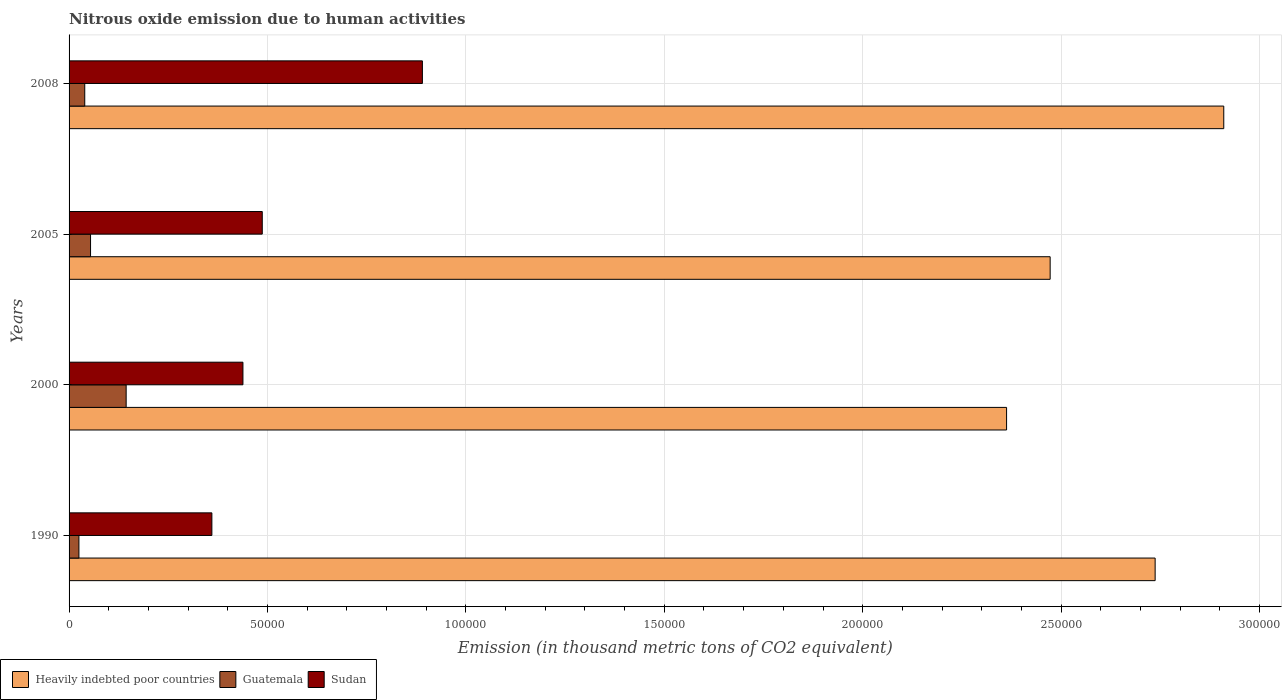How many groups of bars are there?
Keep it short and to the point. 4. How many bars are there on the 2nd tick from the bottom?
Provide a succinct answer. 3. What is the label of the 3rd group of bars from the top?
Your answer should be compact. 2000. In how many cases, is the number of bars for a given year not equal to the number of legend labels?
Your response must be concise. 0. What is the amount of nitrous oxide emitted in Sudan in 2005?
Your response must be concise. 4.87e+04. Across all years, what is the maximum amount of nitrous oxide emitted in Guatemala?
Ensure brevity in your answer.  1.44e+04. Across all years, what is the minimum amount of nitrous oxide emitted in Sudan?
Offer a very short reply. 3.60e+04. What is the total amount of nitrous oxide emitted in Guatemala in the graph?
Offer a very short reply. 2.62e+04. What is the difference between the amount of nitrous oxide emitted in Sudan in 2000 and that in 2005?
Offer a terse response. -4871.9. What is the difference between the amount of nitrous oxide emitted in Heavily indebted poor countries in 1990 and the amount of nitrous oxide emitted in Sudan in 2000?
Keep it short and to the point. 2.30e+05. What is the average amount of nitrous oxide emitted in Guatemala per year?
Keep it short and to the point. 6558.1. In the year 1990, what is the difference between the amount of nitrous oxide emitted in Guatemala and amount of nitrous oxide emitted in Heavily indebted poor countries?
Ensure brevity in your answer.  -2.71e+05. What is the ratio of the amount of nitrous oxide emitted in Guatemala in 2005 to that in 2008?
Your answer should be very brief. 1.37. Is the difference between the amount of nitrous oxide emitted in Guatemala in 2000 and 2008 greater than the difference between the amount of nitrous oxide emitted in Heavily indebted poor countries in 2000 and 2008?
Make the answer very short. Yes. What is the difference between the highest and the second highest amount of nitrous oxide emitted in Guatemala?
Give a very brief answer. 8972.6. What is the difference between the highest and the lowest amount of nitrous oxide emitted in Guatemala?
Your response must be concise. 1.19e+04. In how many years, is the amount of nitrous oxide emitted in Guatemala greater than the average amount of nitrous oxide emitted in Guatemala taken over all years?
Offer a very short reply. 1. What does the 2nd bar from the top in 2005 represents?
Offer a terse response. Guatemala. What does the 2nd bar from the bottom in 1990 represents?
Make the answer very short. Guatemala. Is it the case that in every year, the sum of the amount of nitrous oxide emitted in Guatemala and amount of nitrous oxide emitted in Sudan is greater than the amount of nitrous oxide emitted in Heavily indebted poor countries?
Provide a short and direct response. No. How many bars are there?
Your response must be concise. 12. Are all the bars in the graph horizontal?
Your answer should be compact. Yes. How many years are there in the graph?
Provide a succinct answer. 4. What is the difference between two consecutive major ticks on the X-axis?
Your answer should be very brief. 5.00e+04. Are the values on the major ticks of X-axis written in scientific E-notation?
Provide a succinct answer. No. Does the graph contain any zero values?
Provide a short and direct response. No. How many legend labels are there?
Your answer should be compact. 3. How are the legend labels stacked?
Ensure brevity in your answer.  Horizontal. What is the title of the graph?
Your answer should be very brief. Nitrous oxide emission due to human activities. Does "Belarus" appear as one of the legend labels in the graph?
Provide a succinct answer. No. What is the label or title of the X-axis?
Make the answer very short. Emission (in thousand metric tons of CO2 equivalent). What is the Emission (in thousand metric tons of CO2 equivalent) of Heavily indebted poor countries in 1990?
Your answer should be compact. 2.74e+05. What is the Emission (in thousand metric tons of CO2 equivalent) of Guatemala in 1990?
Make the answer very short. 2483.4. What is the Emission (in thousand metric tons of CO2 equivalent) in Sudan in 1990?
Offer a terse response. 3.60e+04. What is the Emission (in thousand metric tons of CO2 equivalent) of Heavily indebted poor countries in 2000?
Give a very brief answer. 2.36e+05. What is the Emission (in thousand metric tons of CO2 equivalent) in Guatemala in 2000?
Make the answer very short. 1.44e+04. What is the Emission (in thousand metric tons of CO2 equivalent) of Sudan in 2000?
Your response must be concise. 4.38e+04. What is the Emission (in thousand metric tons of CO2 equivalent) of Heavily indebted poor countries in 2005?
Your answer should be very brief. 2.47e+05. What is the Emission (in thousand metric tons of CO2 equivalent) of Guatemala in 2005?
Ensure brevity in your answer.  5413.1. What is the Emission (in thousand metric tons of CO2 equivalent) of Sudan in 2005?
Your answer should be very brief. 4.87e+04. What is the Emission (in thousand metric tons of CO2 equivalent) of Heavily indebted poor countries in 2008?
Your answer should be compact. 2.91e+05. What is the Emission (in thousand metric tons of CO2 equivalent) of Guatemala in 2008?
Give a very brief answer. 3950.2. What is the Emission (in thousand metric tons of CO2 equivalent) of Sudan in 2008?
Offer a terse response. 8.90e+04. Across all years, what is the maximum Emission (in thousand metric tons of CO2 equivalent) of Heavily indebted poor countries?
Give a very brief answer. 2.91e+05. Across all years, what is the maximum Emission (in thousand metric tons of CO2 equivalent) of Guatemala?
Your answer should be very brief. 1.44e+04. Across all years, what is the maximum Emission (in thousand metric tons of CO2 equivalent) of Sudan?
Your response must be concise. 8.90e+04. Across all years, what is the minimum Emission (in thousand metric tons of CO2 equivalent) in Heavily indebted poor countries?
Ensure brevity in your answer.  2.36e+05. Across all years, what is the minimum Emission (in thousand metric tons of CO2 equivalent) in Guatemala?
Give a very brief answer. 2483.4. Across all years, what is the minimum Emission (in thousand metric tons of CO2 equivalent) of Sudan?
Your response must be concise. 3.60e+04. What is the total Emission (in thousand metric tons of CO2 equivalent) in Heavily indebted poor countries in the graph?
Offer a terse response. 1.05e+06. What is the total Emission (in thousand metric tons of CO2 equivalent) of Guatemala in the graph?
Ensure brevity in your answer.  2.62e+04. What is the total Emission (in thousand metric tons of CO2 equivalent) of Sudan in the graph?
Provide a succinct answer. 2.18e+05. What is the difference between the Emission (in thousand metric tons of CO2 equivalent) in Heavily indebted poor countries in 1990 and that in 2000?
Ensure brevity in your answer.  3.74e+04. What is the difference between the Emission (in thousand metric tons of CO2 equivalent) of Guatemala in 1990 and that in 2000?
Give a very brief answer. -1.19e+04. What is the difference between the Emission (in thousand metric tons of CO2 equivalent) of Sudan in 1990 and that in 2000?
Offer a very short reply. -7827.3. What is the difference between the Emission (in thousand metric tons of CO2 equivalent) in Heavily indebted poor countries in 1990 and that in 2005?
Your answer should be compact. 2.65e+04. What is the difference between the Emission (in thousand metric tons of CO2 equivalent) of Guatemala in 1990 and that in 2005?
Give a very brief answer. -2929.7. What is the difference between the Emission (in thousand metric tons of CO2 equivalent) in Sudan in 1990 and that in 2005?
Your answer should be compact. -1.27e+04. What is the difference between the Emission (in thousand metric tons of CO2 equivalent) in Heavily indebted poor countries in 1990 and that in 2008?
Offer a terse response. -1.73e+04. What is the difference between the Emission (in thousand metric tons of CO2 equivalent) of Guatemala in 1990 and that in 2008?
Offer a terse response. -1466.8. What is the difference between the Emission (in thousand metric tons of CO2 equivalent) in Sudan in 1990 and that in 2008?
Offer a very short reply. -5.31e+04. What is the difference between the Emission (in thousand metric tons of CO2 equivalent) of Heavily indebted poor countries in 2000 and that in 2005?
Your answer should be very brief. -1.10e+04. What is the difference between the Emission (in thousand metric tons of CO2 equivalent) in Guatemala in 2000 and that in 2005?
Make the answer very short. 8972.6. What is the difference between the Emission (in thousand metric tons of CO2 equivalent) in Sudan in 2000 and that in 2005?
Provide a short and direct response. -4871.9. What is the difference between the Emission (in thousand metric tons of CO2 equivalent) in Heavily indebted poor countries in 2000 and that in 2008?
Your response must be concise. -5.47e+04. What is the difference between the Emission (in thousand metric tons of CO2 equivalent) of Guatemala in 2000 and that in 2008?
Ensure brevity in your answer.  1.04e+04. What is the difference between the Emission (in thousand metric tons of CO2 equivalent) of Sudan in 2000 and that in 2008?
Keep it short and to the point. -4.52e+04. What is the difference between the Emission (in thousand metric tons of CO2 equivalent) in Heavily indebted poor countries in 2005 and that in 2008?
Your answer should be compact. -4.38e+04. What is the difference between the Emission (in thousand metric tons of CO2 equivalent) of Guatemala in 2005 and that in 2008?
Your answer should be very brief. 1462.9. What is the difference between the Emission (in thousand metric tons of CO2 equivalent) in Sudan in 2005 and that in 2008?
Ensure brevity in your answer.  -4.04e+04. What is the difference between the Emission (in thousand metric tons of CO2 equivalent) of Heavily indebted poor countries in 1990 and the Emission (in thousand metric tons of CO2 equivalent) of Guatemala in 2000?
Make the answer very short. 2.59e+05. What is the difference between the Emission (in thousand metric tons of CO2 equivalent) in Heavily indebted poor countries in 1990 and the Emission (in thousand metric tons of CO2 equivalent) in Sudan in 2000?
Your answer should be compact. 2.30e+05. What is the difference between the Emission (in thousand metric tons of CO2 equivalent) in Guatemala in 1990 and the Emission (in thousand metric tons of CO2 equivalent) in Sudan in 2000?
Your answer should be compact. -4.13e+04. What is the difference between the Emission (in thousand metric tons of CO2 equivalent) in Heavily indebted poor countries in 1990 and the Emission (in thousand metric tons of CO2 equivalent) in Guatemala in 2005?
Offer a terse response. 2.68e+05. What is the difference between the Emission (in thousand metric tons of CO2 equivalent) in Heavily indebted poor countries in 1990 and the Emission (in thousand metric tons of CO2 equivalent) in Sudan in 2005?
Ensure brevity in your answer.  2.25e+05. What is the difference between the Emission (in thousand metric tons of CO2 equivalent) in Guatemala in 1990 and the Emission (in thousand metric tons of CO2 equivalent) in Sudan in 2005?
Provide a short and direct response. -4.62e+04. What is the difference between the Emission (in thousand metric tons of CO2 equivalent) in Heavily indebted poor countries in 1990 and the Emission (in thousand metric tons of CO2 equivalent) in Guatemala in 2008?
Make the answer very short. 2.70e+05. What is the difference between the Emission (in thousand metric tons of CO2 equivalent) of Heavily indebted poor countries in 1990 and the Emission (in thousand metric tons of CO2 equivalent) of Sudan in 2008?
Ensure brevity in your answer.  1.85e+05. What is the difference between the Emission (in thousand metric tons of CO2 equivalent) of Guatemala in 1990 and the Emission (in thousand metric tons of CO2 equivalent) of Sudan in 2008?
Offer a terse response. -8.66e+04. What is the difference between the Emission (in thousand metric tons of CO2 equivalent) in Heavily indebted poor countries in 2000 and the Emission (in thousand metric tons of CO2 equivalent) in Guatemala in 2005?
Provide a short and direct response. 2.31e+05. What is the difference between the Emission (in thousand metric tons of CO2 equivalent) in Heavily indebted poor countries in 2000 and the Emission (in thousand metric tons of CO2 equivalent) in Sudan in 2005?
Give a very brief answer. 1.88e+05. What is the difference between the Emission (in thousand metric tons of CO2 equivalent) in Guatemala in 2000 and the Emission (in thousand metric tons of CO2 equivalent) in Sudan in 2005?
Your answer should be very brief. -3.43e+04. What is the difference between the Emission (in thousand metric tons of CO2 equivalent) of Heavily indebted poor countries in 2000 and the Emission (in thousand metric tons of CO2 equivalent) of Guatemala in 2008?
Your response must be concise. 2.32e+05. What is the difference between the Emission (in thousand metric tons of CO2 equivalent) of Heavily indebted poor countries in 2000 and the Emission (in thousand metric tons of CO2 equivalent) of Sudan in 2008?
Keep it short and to the point. 1.47e+05. What is the difference between the Emission (in thousand metric tons of CO2 equivalent) in Guatemala in 2000 and the Emission (in thousand metric tons of CO2 equivalent) in Sudan in 2008?
Your answer should be very brief. -7.47e+04. What is the difference between the Emission (in thousand metric tons of CO2 equivalent) of Heavily indebted poor countries in 2005 and the Emission (in thousand metric tons of CO2 equivalent) of Guatemala in 2008?
Give a very brief answer. 2.43e+05. What is the difference between the Emission (in thousand metric tons of CO2 equivalent) of Heavily indebted poor countries in 2005 and the Emission (in thousand metric tons of CO2 equivalent) of Sudan in 2008?
Your response must be concise. 1.58e+05. What is the difference between the Emission (in thousand metric tons of CO2 equivalent) of Guatemala in 2005 and the Emission (in thousand metric tons of CO2 equivalent) of Sudan in 2008?
Provide a succinct answer. -8.36e+04. What is the average Emission (in thousand metric tons of CO2 equivalent) of Heavily indebted poor countries per year?
Provide a short and direct response. 2.62e+05. What is the average Emission (in thousand metric tons of CO2 equivalent) in Guatemala per year?
Ensure brevity in your answer.  6558.1. What is the average Emission (in thousand metric tons of CO2 equivalent) in Sudan per year?
Your answer should be compact. 5.44e+04. In the year 1990, what is the difference between the Emission (in thousand metric tons of CO2 equivalent) in Heavily indebted poor countries and Emission (in thousand metric tons of CO2 equivalent) in Guatemala?
Provide a short and direct response. 2.71e+05. In the year 1990, what is the difference between the Emission (in thousand metric tons of CO2 equivalent) of Heavily indebted poor countries and Emission (in thousand metric tons of CO2 equivalent) of Sudan?
Keep it short and to the point. 2.38e+05. In the year 1990, what is the difference between the Emission (in thousand metric tons of CO2 equivalent) of Guatemala and Emission (in thousand metric tons of CO2 equivalent) of Sudan?
Your response must be concise. -3.35e+04. In the year 2000, what is the difference between the Emission (in thousand metric tons of CO2 equivalent) of Heavily indebted poor countries and Emission (in thousand metric tons of CO2 equivalent) of Guatemala?
Offer a terse response. 2.22e+05. In the year 2000, what is the difference between the Emission (in thousand metric tons of CO2 equivalent) of Heavily indebted poor countries and Emission (in thousand metric tons of CO2 equivalent) of Sudan?
Keep it short and to the point. 1.92e+05. In the year 2000, what is the difference between the Emission (in thousand metric tons of CO2 equivalent) of Guatemala and Emission (in thousand metric tons of CO2 equivalent) of Sudan?
Provide a short and direct response. -2.94e+04. In the year 2005, what is the difference between the Emission (in thousand metric tons of CO2 equivalent) in Heavily indebted poor countries and Emission (in thousand metric tons of CO2 equivalent) in Guatemala?
Your answer should be compact. 2.42e+05. In the year 2005, what is the difference between the Emission (in thousand metric tons of CO2 equivalent) in Heavily indebted poor countries and Emission (in thousand metric tons of CO2 equivalent) in Sudan?
Keep it short and to the point. 1.99e+05. In the year 2005, what is the difference between the Emission (in thousand metric tons of CO2 equivalent) of Guatemala and Emission (in thousand metric tons of CO2 equivalent) of Sudan?
Provide a succinct answer. -4.33e+04. In the year 2008, what is the difference between the Emission (in thousand metric tons of CO2 equivalent) in Heavily indebted poor countries and Emission (in thousand metric tons of CO2 equivalent) in Guatemala?
Provide a succinct answer. 2.87e+05. In the year 2008, what is the difference between the Emission (in thousand metric tons of CO2 equivalent) in Heavily indebted poor countries and Emission (in thousand metric tons of CO2 equivalent) in Sudan?
Give a very brief answer. 2.02e+05. In the year 2008, what is the difference between the Emission (in thousand metric tons of CO2 equivalent) of Guatemala and Emission (in thousand metric tons of CO2 equivalent) of Sudan?
Your answer should be compact. -8.51e+04. What is the ratio of the Emission (in thousand metric tons of CO2 equivalent) in Heavily indebted poor countries in 1990 to that in 2000?
Your answer should be compact. 1.16. What is the ratio of the Emission (in thousand metric tons of CO2 equivalent) in Guatemala in 1990 to that in 2000?
Provide a succinct answer. 0.17. What is the ratio of the Emission (in thousand metric tons of CO2 equivalent) in Sudan in 1990 to that in 2000?
Your answer should be compact. 0.82. What is the ratio of the Emission (in thousand metric tons of CO2 equivalent) in Heavily indebted poor countries in 1990 to that in 2005?
Your answer should be compact. 1.11. What is the ratio of the Emission (in thousand metric tons of CO2 equivalent) in Guatemala in 1990 to that in 2005?
Provide a short and direct response. 0.46. What is the ratio of the Emission (in thousand metric tons of CO2 equivalent) in Sudan in 1990 to that in 2005?
Offer a terse response. 0.74. What is the ratio of the Emission (in thousand metric tons of CO2 equivalent) of Heavily indebted poor countries in 1990 to that in 2008?
Give a very brief answer. 0.94. What is the ratio of the Emission (in thousand metric tons of CO2 equivalent) of Guatemala in 1990 to that in 2008?
Provide a succinct answer. 0.63. What is the ratio of the Emission (in thousand metric tons of CO2 equivalent) of Sudan in 1990 to that in 2008?
Your answer should be compact. 0.4. What is the ratio of the Emission (in thousand metric tons of CO2 equivalent) of Heavily indebted poor countries in 2000 to that in 2005?
Offer a terse response. 0.96. What is the ratio of the Emission (in thousand metric tons of CO2 equivalent) of Guatemala in 2000 to that in 2005?
Provide a succinct answer. 2.66. What is the ratio of the Emission (in thousand metric tons of CO2 equivalent) of Sudan in 2000 to that in 2005?
Provide a short and direct response. 0.9. What is the ratio of the Emission (in thousand metric tons of CO2 equivalent) in Heavily indebted poor countries in 2000 to that in 2008?
Give a very brief answer. 0.81. What is the ratio of the Emission (in thousand metric tons of CO2 equivalent) of Guatemala in 2000 to that in 2008?
Offer a terse response. 3.64. What is the ratio of the Emission (in thousand metric tons of CO2 equivalent) in Sudan in 2000 to that in 2008?
Keep it short and to the point. 0.49. What is the ratio of the Emission (in thousand metric tons of CO2 equivalent) of Heavily indebted poor countries in 2005 to that in 2008?
Offer a very short reply. 0.85. What is the ratio of the Emission (in thousand metric tons of CO2 equivalent) of Guatemala in 2005 to that in 2008?
Give a very brief answer. 1.37. What is the ratio of the Emission (in thousand metric tons of CO2 equivalent) of Sudan in 2005 to that in 2008?
Ensure brevity in your answer.  0.55. What is the difference between the highest and the second highest Emission (in thousand metric tons of CO2 equivalent) of Heavily indebted poor countries?
Your answer should be very brief. 1.73e+04. What is the difference between the highest and the second highest Emission (in thousand metric tons of CO2 equivalent) of Guatemala?
Give a very brief answer. 8972.6. What is the difference between the highest and the second highest Emission (in thousand metric tons of CO2 equivalent) in Sudan?
Provide a short and direct response. 4.04e+04. What is the difference between the highest and the lowest Emission (in thousand metric tons of CO2 equivalent) in Heavily indebted poor countries?
Provide a short and direct response. 5.47e+04. What is the difference between the highest and the lowest Emission (in thousand metric tons of CO2 equivalent) of Guatemala?
Provide a succinct answer. 1.19e+04. What is the difference between the highest and the lowest Emission (in thousand metric tons of CO2 equivalent) of Sudan?
Provide a succinct answer. 5.31e+04. 